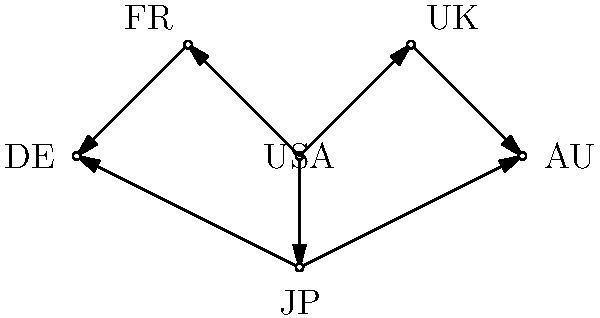Based on the network diagram representing international medical research collaborations, which country appears to be the most central hub for collaborative efforts? To determine the most central hub for collaborative efforts, we need to analyze the connections in the network diagram:

1. Count the number of direct connections for each country:
   USA: 3 connections (to UK, FR, JP)
   UK: 2 connections (to USA, AU)
   FR: 2 connections (to USA, DE)
   JP: 3 connections (to USA, AU, DE)
   AU: 2 connections (to UK, JP)
   DE: 2 connections (to FR, JP)

2. Evaluate the position and influence:
   USA is directly connected to 3 other countries and indirectly connected to all others.
   JP is also directly connected to 3 countries but has a slightly less central position.

3. Consider the flow of information:
   USA appears to be a key intermediary between European (UK, FR) and Asian-Pacific (JP) partners.

4. Assess global reach:
   USA's connections span across different continents, indicating a broader global influence.

Based on these factors, the USA emerges as the most central hub for collaborative efforts in this network of international medical research collaborations.
Answer: USA 